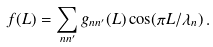<formula> <loc_0><loc_0><loc_500><loc_500>f ( L ) = \sum _ { n n ^ { \prime } } g _ { n n ^ { \prime } } ( L ) \cos ( \pi L / \lambda _ { n } ) \, .</formula> 